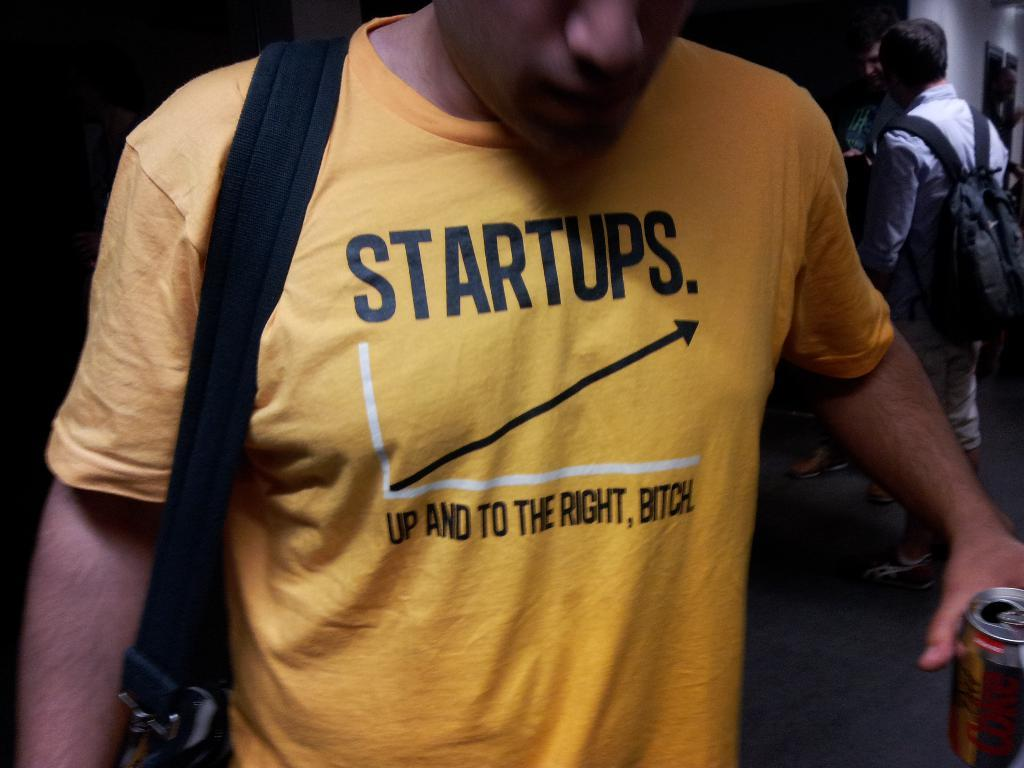<image>
Relay a brief, clear account of the picture shown. A man in a yellow shirt with a graph entitled Startups. 